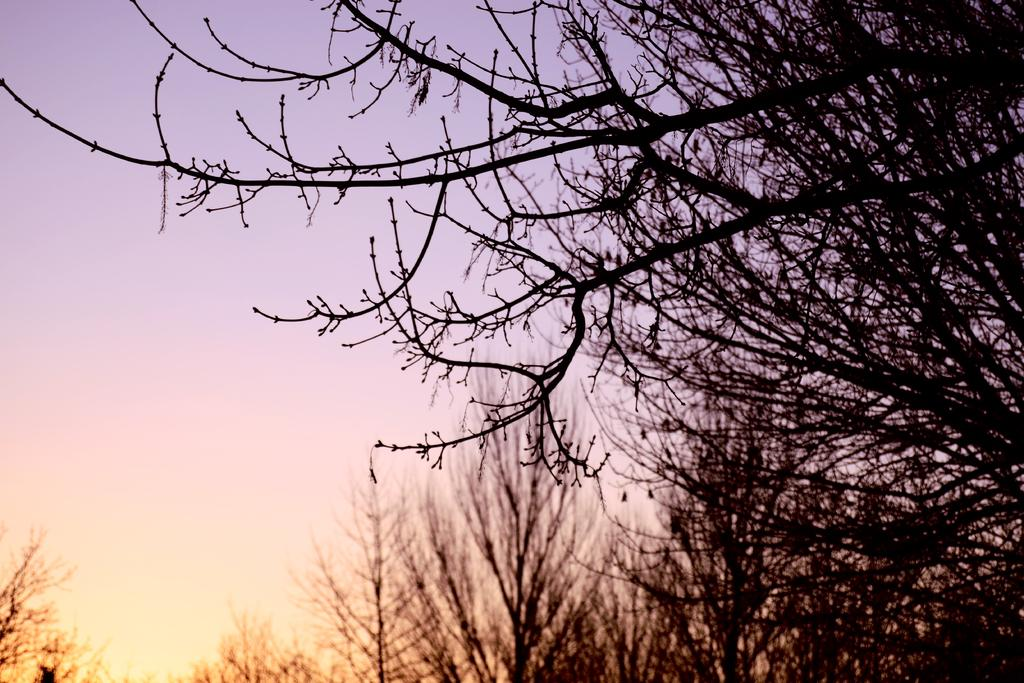What type of vegetation can be seen in the image? There is a group of trees in the image. What else is visible in the image besides the trees? The sky is visible in the image. What type of celery can be seen growing among the trees in the image? There is no celery present in the image; it only features a group of trees and the sky. How does the wind affect the trees in the image? The image does not show any wind or its effects on the trees; it only shows the trees and the sky. 